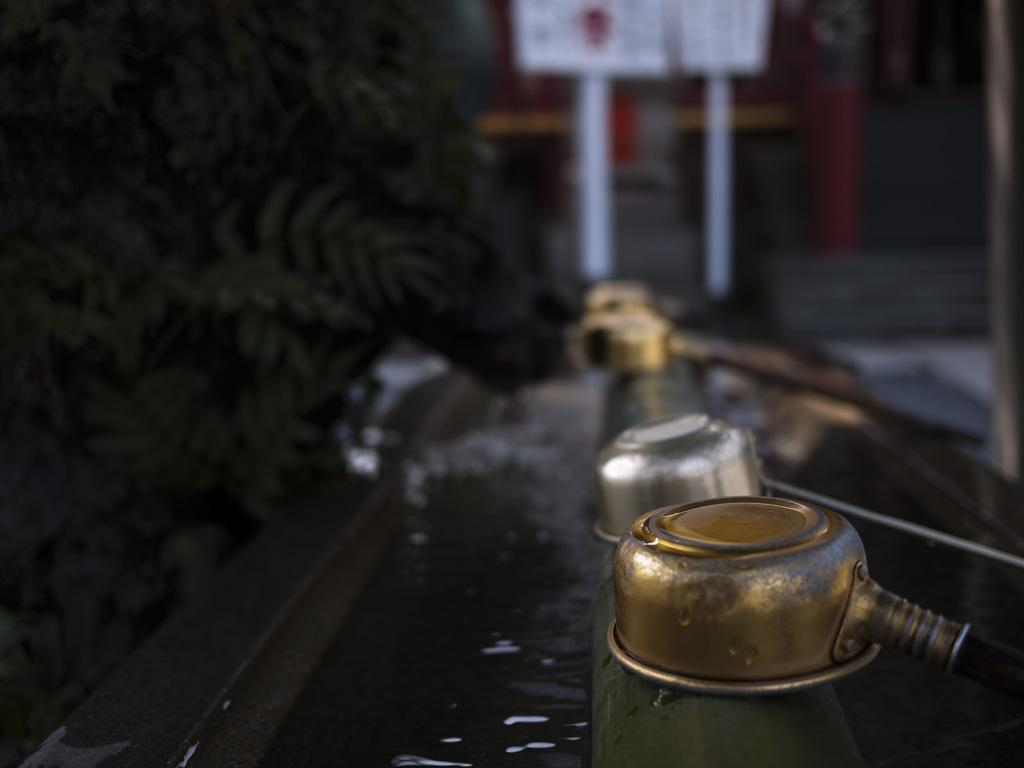What colors are present on the objects on the pipe in the image? There are silver and golden color things on a pipe in the image. What can be seen on the left side of the image? There are trees on the left side of the image. What is visible in the background of the image? There is a board visible in the background of the image. What type of disease is being treated on the board in the image? There is no indication of a disease or any medical treatment in the image; it features silver and golden objects on a pipe, trees on the left side, and a board in the background. 